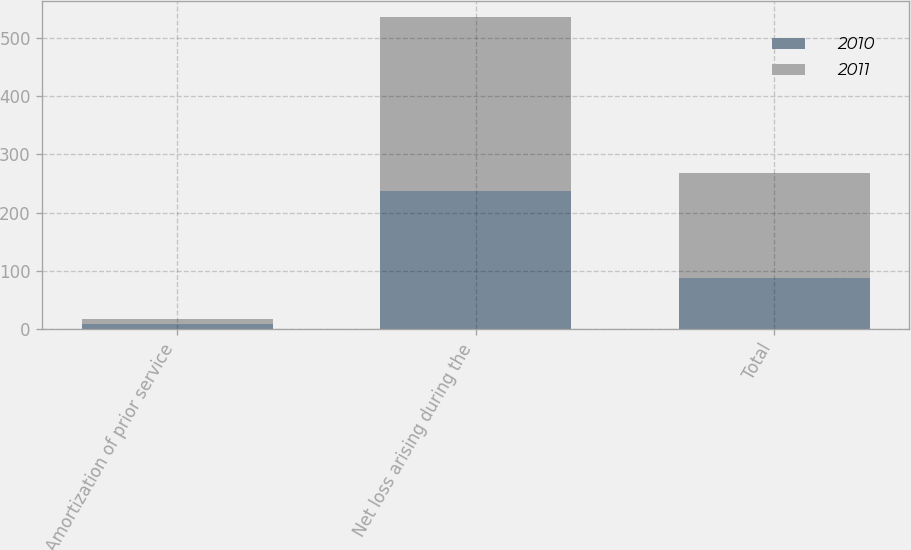<chart> <loc_0><loc_0><loc_500><loc_500><stacked_bar_chart><ecel><fcel>Amortization of prior service<fcel>Net loss arising during the<fcel>Total<nl><fcel>2010<fcel>9<fcel>237<fcel>87<nl><fcel>2011<fcel>9<fcel>298<fcel>180<nl></chart> 